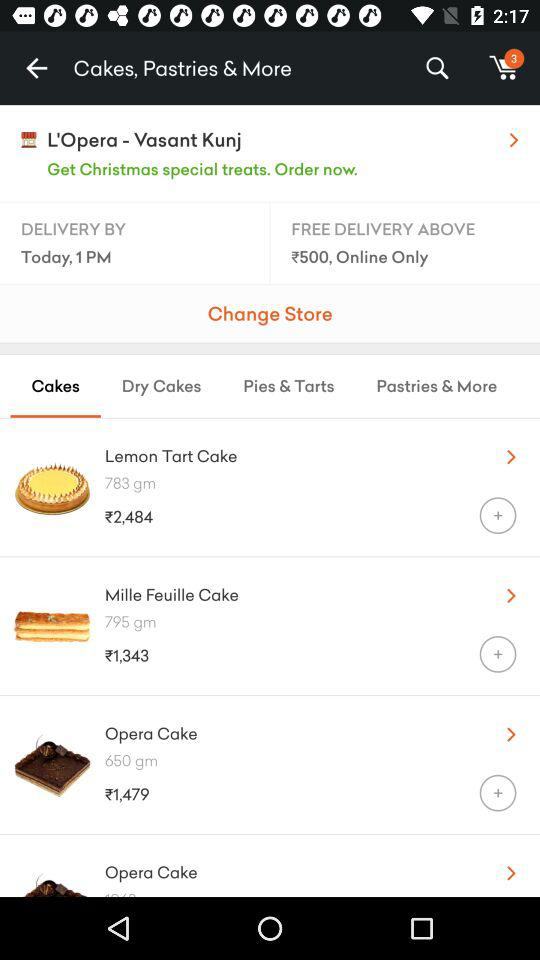What is the weight of the "Opera Cake"? The weight of the "Opera Cake" is 650 grams. 